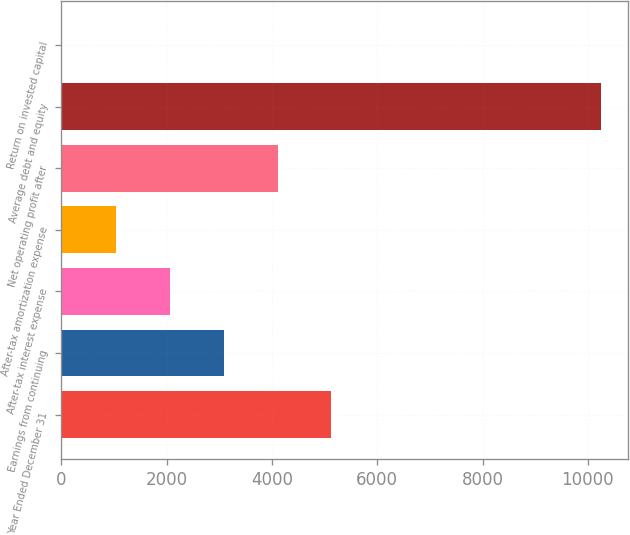Convert chart. <chart><loc_0><loc_0><loc_500><loc_500><bar_chart><fcel>Year Ended December 31<fcel>Earnings from continuing<fcel>After-tax interest expense<fcel>After-tax amortization expense<fcel>Net operating profit after<fcel>Average debt and equity<fcel>Return on invested capital<nl><fcel>5131.15<fcel>3084.01<fcel>2060.44<fcel>1036.87<fcel>4107.58<fcel>10249<fcel>13.3<nl></chart> 